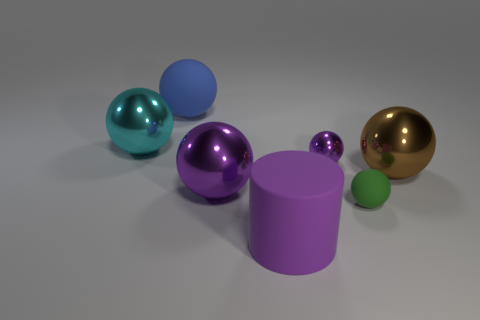Subtract all brown cylinders. How many purple balls are left? 2 Subtract all cyan spheres. How many spheres are left? 5 Add 3 yellow metallic spheres. How many objects exist? 10 Subtract 4 spheres. How many spheres are left? 2 Subtract all purple balls. How many balls are left? 4 Subtract all purple spheres. Subtract all yellow blocks. How many spheres are left? 4 Subtract all balls. How many objects are left? 1 Add 4 tiny red cylinders. How many tiny red cylinders exist? 4 Subtract 0 cyan cylinders. How many objects are left? 7 Subtract all big red cylinders. Subtract all green rubber things. How many objects are left? 6 